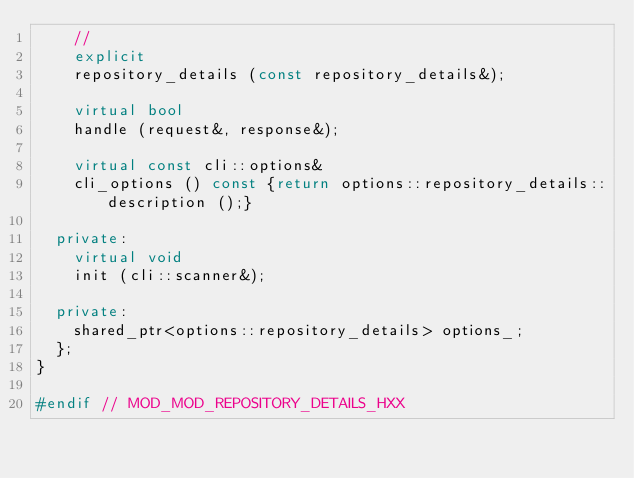<code> <loc_0><loc_0><loc_500><loc_500><_C++_>    //
    explicit
    repository_details (const repository_details&);

    virtual bool
    handle (request&, response&);

    virtual const cli::options&
    cli_options () const {return options::repository_details::description ();}

  private:
    virtual void
    init (cli::scanner&);

  private:
    shared_ptr<options::repository_details> options_;
  };
}

#endif // MOD_MOD_REPOSITORY_DETAILS_HXX
</code> 